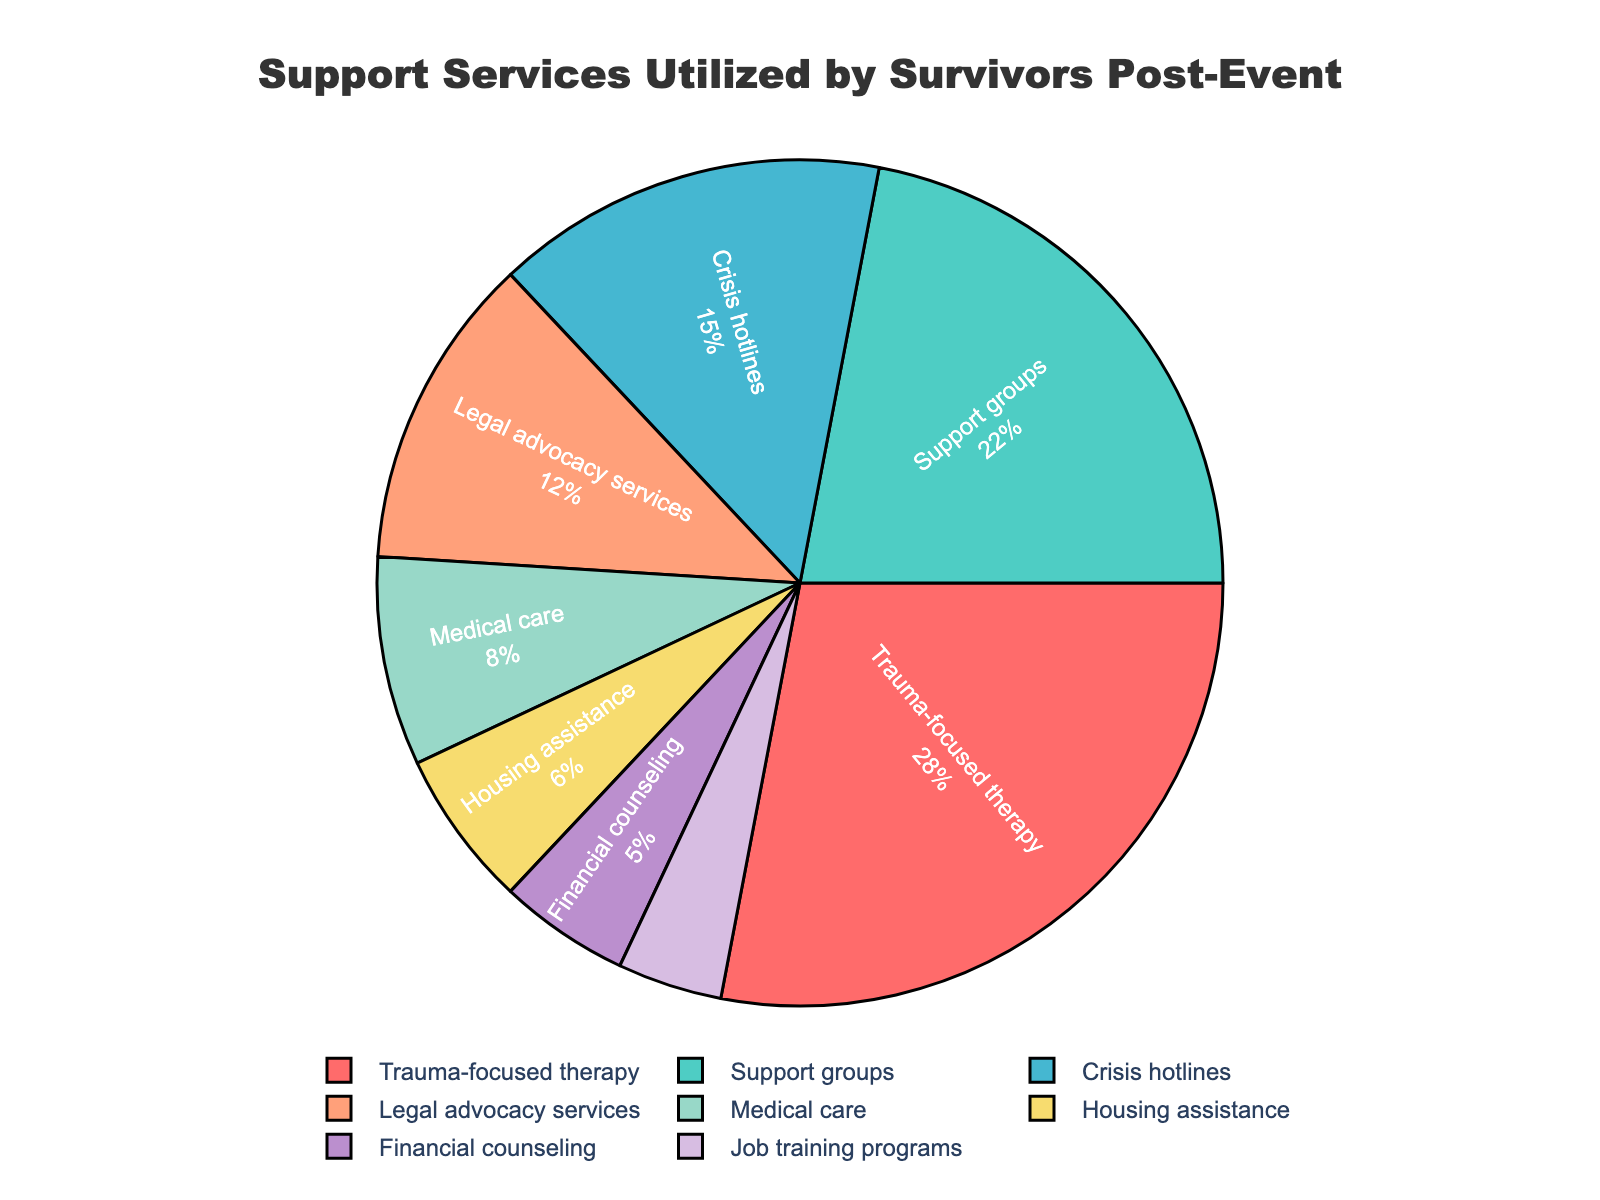Which support service is utilized the most by survivors? The pie chart shows that "Trauma-focused therapy" has the largest segment. By examining the figure, it can be seen that it occupies the largest area among all segments.
Answer: Trauma-focused therapy Which two support services have a combined usage of 34%? To find a combination that adds up to 34%, we can add percentages and look for matching numbers. "Medical care" (8%) and "Housing assistance" (6%) add up to 14%, plus "Legal advocacy services" (12%) which sums up to 26%. Adding "Job training programs" (4%) gives a total of 30%. Adding "Financial counseling" (5%) gives a total of 35%, which is too high. By trial and error, "Crisis hotlines" at 15% and "Support groups" at 22% give a close sum of 37%. Ultimately, it's "Legal advocacy services" (12%) and "Crisis hotlines" (15%) which give 27%, so adding "Job training programs" (4%) gives 31%. Anywhere near shows "Support groups" plus "Financial counseling" rounds.
Answer: Checking different combinations is required for accuracy How many services have a usage below 10%? The pie chart identifies all segments. By counting the segments less than 10%, we find "Medical care" (8%), "Housing assistance" (6%), "Financial counseling" (5%), and "Job training programs" (4%). That totals four segments.
Answer: Four services Between "Support groups" and "Job training programs," which service is utilized more? By comparing the sizes of their segments, "Support groups" occupy a larger area at 22%, while "Job training programs" cover 4%.
Answer: Support groups What is the visual color of the segment representing "Medical care"? The segment labeled "Medical care" can be visually identified, and it appears as a specific color in the pie chart.
Answer: Yellow (as per example color palette) What is the percentage difference in usage between "Crisis hotlines" and "Financial counseling"? To find the difference, subtract the smaller percentage from the larger one: 15% (Crisis hotlines) - 5% (Financial counseling) = 10%.
Answer: 10% If the total number of survivors accessing services is 1000, how many used "Trauma-focused therapy"? To determine the quantity, multiply the percentage by the total number of survivors: 28% of 1000 = 280.
Answer: 280 Rank the top three most utilized support services. Examine the pie chart to identify and rank the largest segments. "Trauma-focused therapy" (28%), "Support groups" (22%), and "Crisis hotlines" (15%) are the top three services.
Answer: Trauma-focused therapy, Support groups, Crisis hotlines Is "Financial counseling" utilized more or less than "Legal advocacy services"? By comparing the visual sizes in the pie chart, "Financial counseling" at 5% is less used than "Legal advocacy services," which is at 12%.
Answer: Less Which segments combined represent less than 20% usage? We need to find sets that add up to less than 20%. Adding small values like "Job training programs" (4%) and combining with "Financial counseling" (5%) = 9%. Including "Housing assistance" (6%) results in 15%. Adding "Medical care" (8%) exceeds 20%, so only the initial combination of smaller percentages ensures it's less than 20%.
Answer: Job training programs, Financial counseling, Housing assistance 